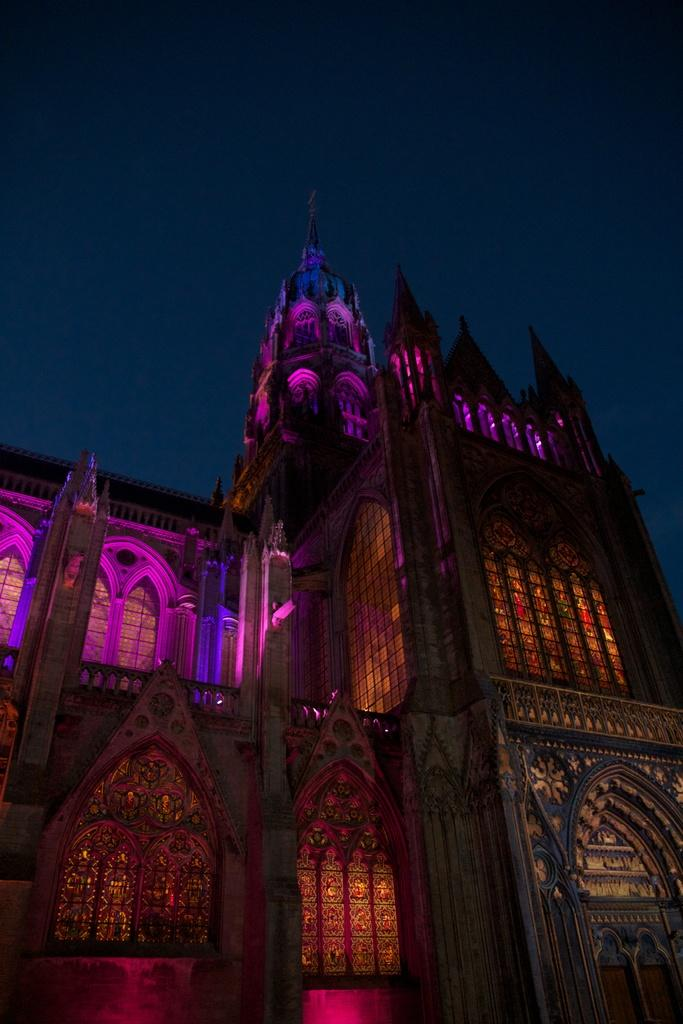What type of structure is present in the image? There is a building in the image. What can be seen in the background of the image? The sky is visible in the background of the image. What year is the discussion taking place in the image? There is no discussion taking place in the image, as it only features a building and the sky. Is there a volcano visible in the image? No, there is no volcano present in the image. 